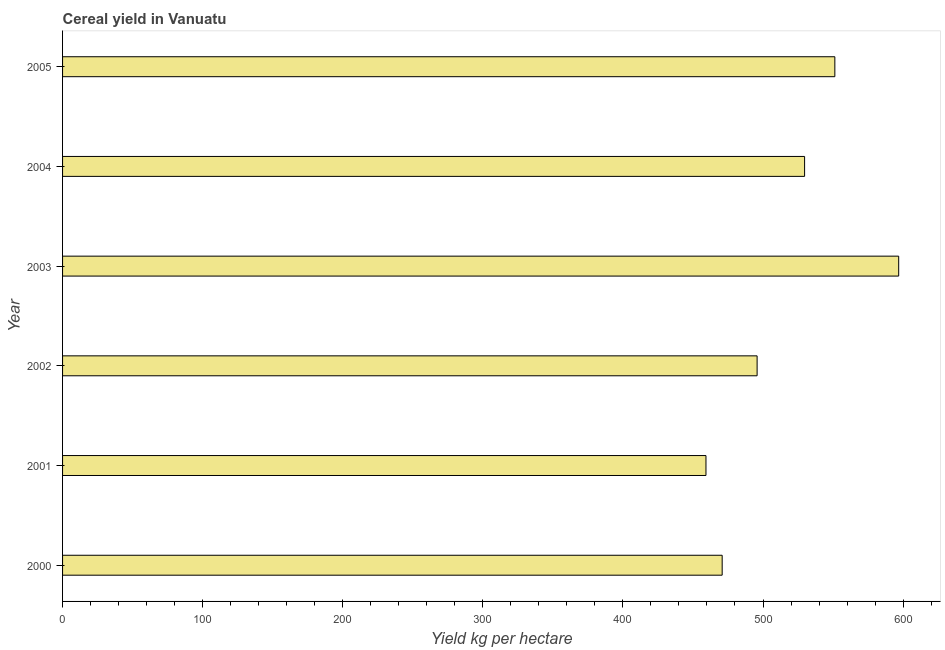Does the graph contain any zero values?
Your response must be concise. No. Does the graph contain grids?
Provide a short and direct response. No. What is the title of the graph?
Offer a terse response. Cereal yield in Vanuatu. What is the label or title of the X-axis?
Offer a terse response. Yield kg per hectare. What is the label or title of the Y-axis?
Give a very brief answer. Year. What is the cereal yield in 2002?
Offer a very short reply. 495.79. Across all years, what is the maximum cereal yield?
Offer a very short reply. 596.86. Across all years, what is the minimum cereal yield?
Your answer should be compact. 459.29. In which year was the cereal yield minimum?
Your response must be concise. 2001. What is the sum of the cereal yield?
Offer a terse response. 3103.78. What is the difference between the cereal yield in 2001 and 2002?
Ensure brevity in your answer.  -36.5. What is the average cereal yield per year?
Provide a succinct answer. 517.3. What is the median cereal yield?
Provide a succinct answer. 512.74. In how many years, is the cereal yield greater than 400 kg per hectare?
Your answer should be very brief. 6. What is the ratio of the cereal yield in 2003 to that in 2004?
Your answer should be compact. 1.13. Is the cereal yield in 2001 less than that in 2005?
Provide a short and direct response. Yes. What is the difference between the highest and the second highest cereal yield?
Your answer should be very brief. 45.58. Is the sum of the cereal yield in 2003 and 2004 greater than the maximum cereal yield across all years?
Offer a terse response. Yes. What is the difference between the highest and the lowest cereal yield?
Give a very brief answer. 137.57. How many bars are there?
Provide a succinct answer. 6. How many years are there in the graph?
Your answer should be very brief. 6. What is the difference between two consecutive major ticks on the X-axis?
Offer a very short reply. 100. Are the values on the major ticks of X-axis written in scientific E-notation?
Your answer should be very brief. No. What is the Yield kg per hectare of 2000?
Keep it short and to the point. 470.86. What is the Yield kg per hectare of 2001?
Ensure brevity in your answer.  459.29. What is the Yield kg per hectare in 2002?
Your answer should be very brief. 495.79. What is the Yield kg per hectare in 2003?
Provide a succinct answer. 596.86. What is the Yield kg per hectare in 2004?
Your answer should be very brief. 529.69. What is the Yield kg per hectare of 2005?
Provide a short and direct response. 551.28. What is the difference between the Yield kg per hectare in 2000 and 2001?
Give a very brief answer. 11.57. What is the difference between the Yield kg per hectare in 2000 and 2002?
Your response must be concise. -24.93. What is the difference between the Yield kg per hectare in 2000 and 2003?
Your answer should be compact. -126. What is the difference between the Yield kg per hectare in 2000 and 2004?
Offer a terse response. -58.84. What is the difference between the Yield kg per hectare in 2000 and 2005?
Offer a very short reply. -80.42. What is the difference between the Yield kg per hectare in 2001 and 2002?
Offer a terse response. -36.5. What is the difference between the Yield kg per hectare in 2001 and 2003?
Provide a short and direct response. -137.57. What is the difference between the Yield kg per hectare in 2001 and 2004?
Provide a succinct answer. -70.4. What is the difference between the Yield kg per hectare in 2001 and 2005?
Give a very brief answer. -91.99. What is the difference between the Yield kg per hectare in 2002 and 2003?
Offer a terse response. -101.06. What is the difference between the Yield kg per hectare in 2002 and 2004?
Provide a short and direct response. -33.9. What is the difference between the Yield kg per hectare in 2002 and 2005?
Your answer should be compact. -55.49. What is the difference between the Yield kg per hectare in 2003 and 2004?
Your answer should be compact. 67.17. What is the difference between the Yield kg per hectare in 2003 and 2005?
Provide a short and direct response. 45.58. What is the difference between the Yield kg per hectare in 2004 and 2005?
Give a very brief answer. -21.59. What is the ratio of the Yield kg per hectare in 2000 to that in 2002?
Give a very brief answer. 0.95. What is the ratio of the Yield kg per hectare in 2000 to that in 2003?
Offer a very short reply. 0.79. What is the ratio of the Yield kg per hectare in 2000 to that in 2004?
Your answer should be very brief. 0.89. What is the ratio of the Yield kg per hectare in 2000 to that in 2005?
Provide a short and direct response. 0.85. What is the ratio of the Yield kg per hectare in 2001 to that in 2002?
Your answer should be very brief. 0.93. What is the ratio of the Yield kg per hectare in 2001 to that in 2003?
Keep it short and to the point. 0.77. What is the ratio of the Yield kg per hectare in 2001 to that in 2004?
Provide a short and direct response. 0.87. What is the ratio of the Yield kg per hectare in 2001 to that in 2005?
Your answer should be very brief. 0.83. What is the ratio of the Yield kg per hectare in 2002 to that in 2003?
Ensure brevity in your answer.  0.83. What is the ratio of the Yield kg per hectare in 2002 to that in 2004?
Provide a short and direct response. 0.94. What is the ratio of the Yield kg per hectare in 2002 to that in 2005?
Your response must be concise. 0.9. What is the ratio of the Yield kg per hectare in 2003 to that in 2004?
Give a very brief answer. 1.13. What is the ratio of the Yield kg per hectare in 2003 to that in 2005?
Your answer should be compact. 1.08. What is the ratio of the Yield kg per hectare in 2004 to that in 2005?
Your answer should be compact. 0.96. 